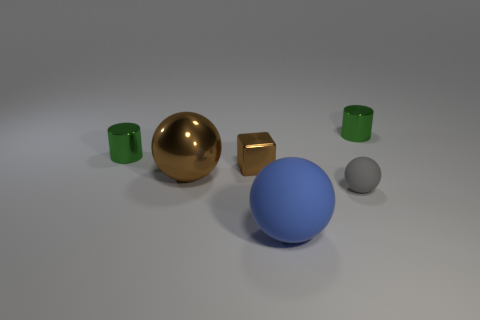What material is the ball that is the same size as the block?
Give a very brief answer. Rubber. Are there any small objects made of the same material as the large brown ball?
Provide a succinct answer. Yes. There is a thing that is both behind the large brown object and on the left side of the small brown object; what color is it?
Make the answer very short. Green. How many other objects are the same color as the small cube?
Offer a very short reply. 1. What material is the large blue ball that is to the left of the cylinder that is on the right side of the shiny cylinder that is on the left side of the small ball?
Provide a short and direct response. Rubber. What number of cylinders are green metallic objects or small gray things?
Your response must be concise. 2. There is a green shiny cylinder on the left side of the big ball that is right of the big brown metal ball; how many green shiny cylinders are behind it?
Keep it short and to the point. 1. Is the shape of the large brown object the same as the tiny matte thing?
Keep it short and to the point. Yes. Are the tiny thing that is to the left of the shiny sphere and the big thing that is to the right of the small brown cube made of the same material?
Your answer should be very brief. No. What number of things are big things that are to the left of the blue matte object or tiny shiny things to the left of the blue rubber object?
Provide a succinct answer. 3. 